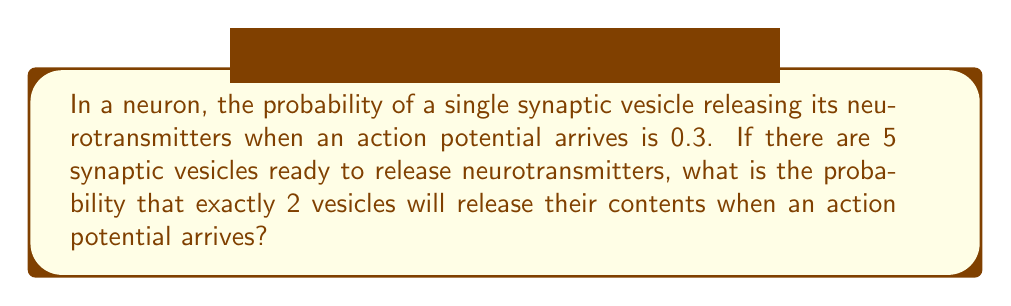Can you answer this question? To solve this problem, we can use the binomial probability formula. This scenario fits a binomial distribution because:

1. There are a fixed number of trials (5 vesicles).
2. Each trial has two possible outcomes (release or not release).
3. The probability of success (release) is the same for each trial (0.3).
4. The trials are independent.

The binomial probability formula is:

$$ P(X = k) = \binom{n}{k} p^k (1-p)^{n-k} $$

Where:
- $n$ is the number of trials (5 vesicles)
- $k$ is the number of successes we're looking for (2 releases)
- $p$ is the probability of success on each trial (0.3)

Let's substitute these values:

$$ P(X = 2) = \binom{5}{2} (0.3)^2 (1-0.3)^{5-2} $$

Now, let's calculate step by step:

1. Calculate $\binom{5}{2}$:
   $\binom{5}{2} = \frac{5!}{2!(5-2)!} = \frac{5 \cdot 4}{2 \cdot 1} = 10$

2. Calculate $(0.3)^2$:
   $(0.3)^2 = 0.09$

3. Calculate $(1-0.3)^{5-2}$:
   $(0.7)^3 = 0.343$

4. Multiply all parts together:
   $10 \cdot 0.09 \cdot 0.343 = 0.30870$

Therefore, the probability of exactly 2 vesicles releasing their contents is approximately 0.3087 or 30.87%.
Answer: 0.3087 or 30.87% 